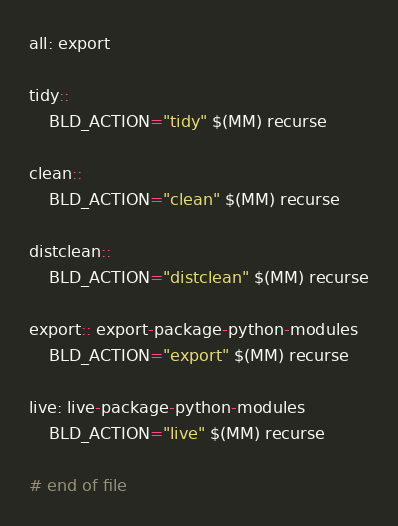<code> <loc_0><loc_0><loc_500><loc_500><_ObjectiveC_>all: export

tidy::
	BLD_ACTION="tidy" $(MM) recurse

clean::
	BLD_ACTION="clean" $(MM) recurse

distclean::
	BLD_ACTION="distclean" $(MM) recurse

export:: export-package-python-modules
	BLD_ACTION="export" $(MM) recurse

live: live-package-python-modules
	BLD_ACTION="live" $(MM) recurse

# end of file
</code> 